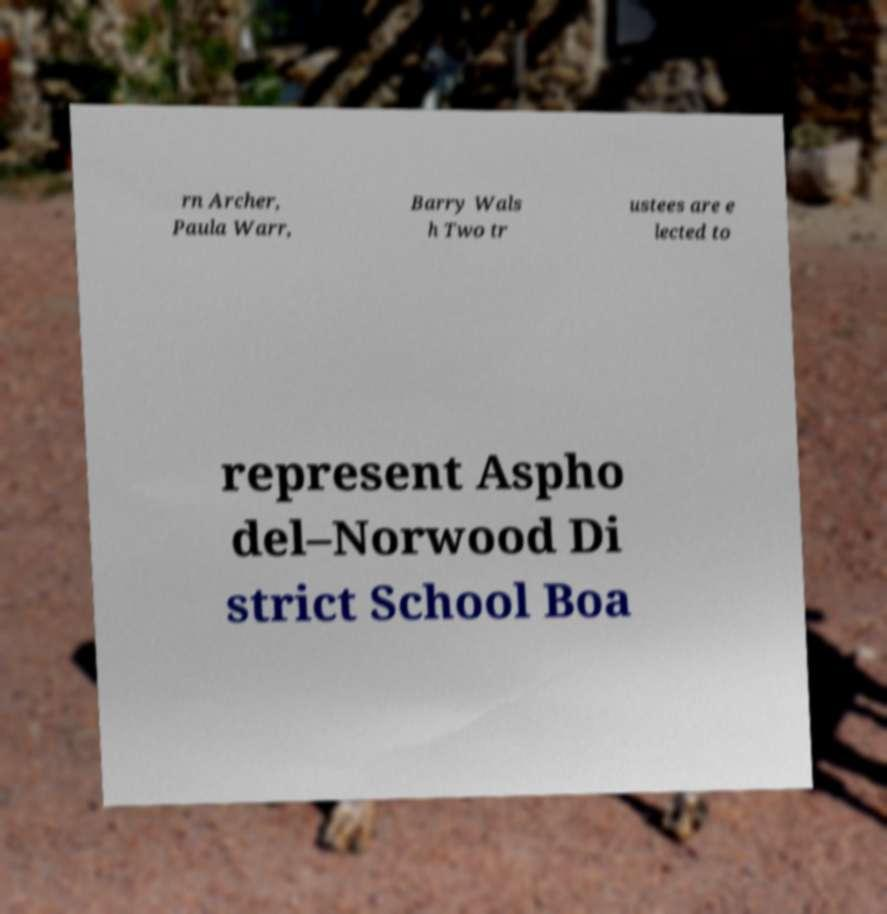What messages or text are displayed in this image? I need them in a readable, typed format. rn Archer, Paula Warr, Barry Wals h Two tr ustees are e lected to represent Aspho del–Norwood Di strict School Boa 